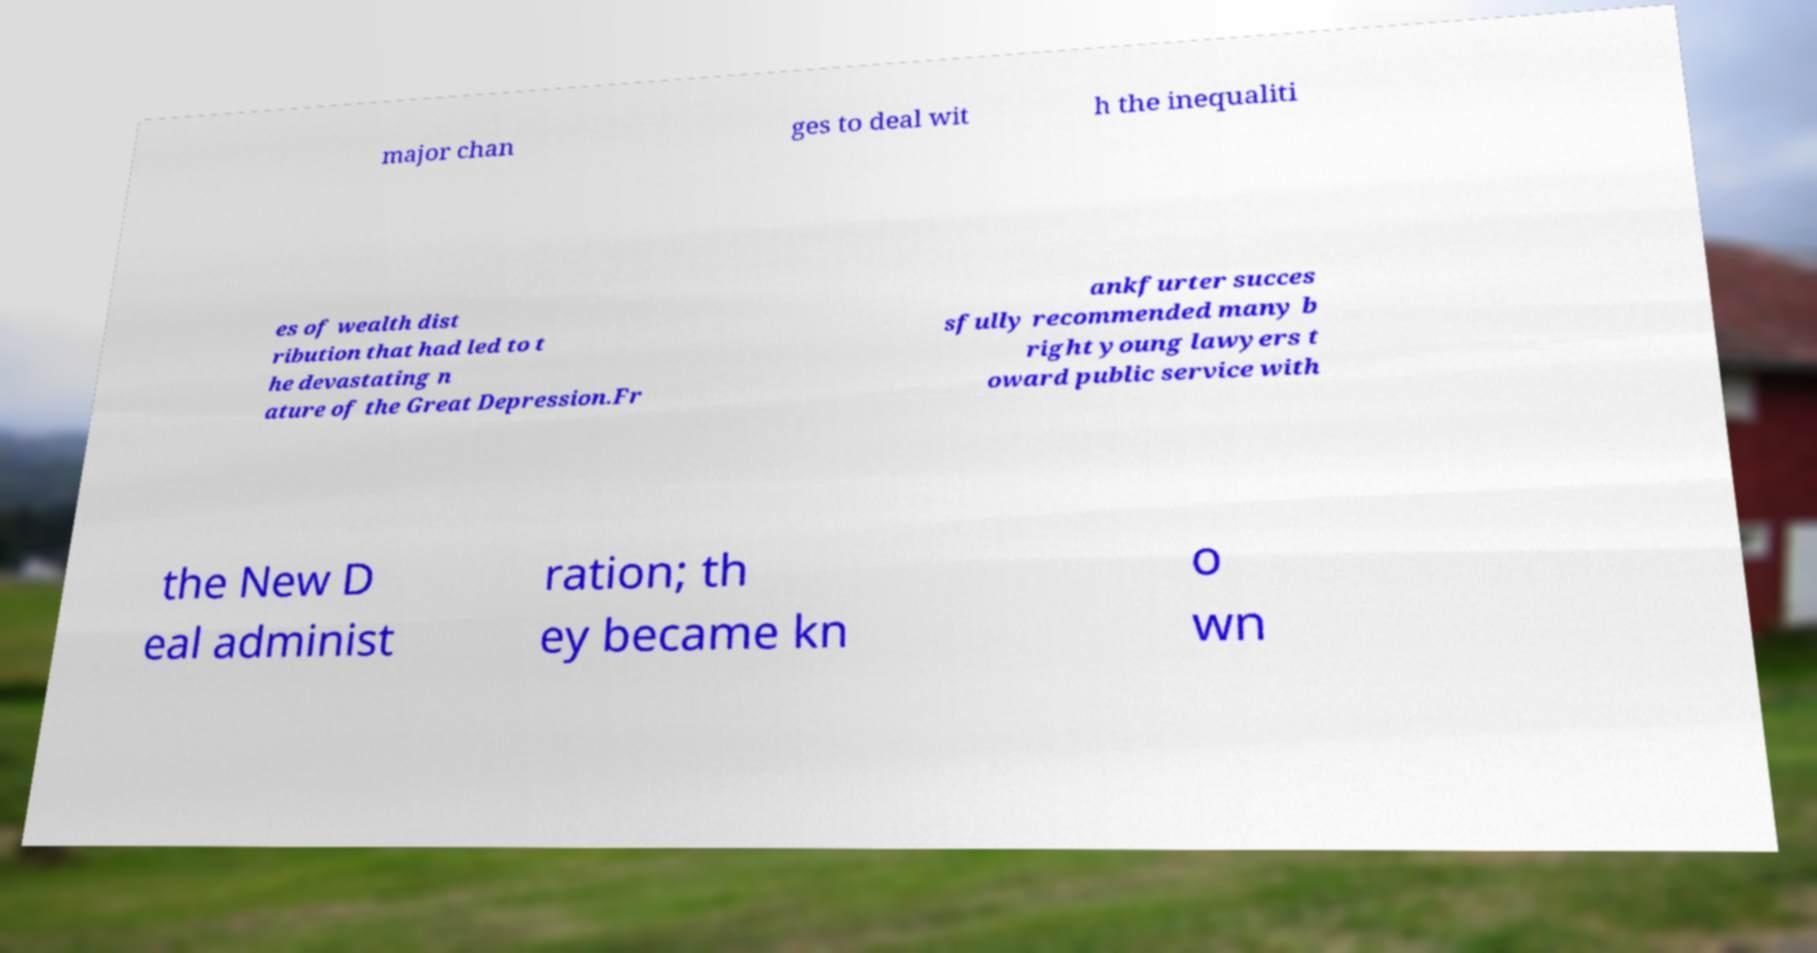There's text embedded in this image that I need extracted. Can you transcribe it verbatim? major chan ges to deal wit h the inequaliti es of wealth dist ribution that had led to t he devastating n ature of the Great Depression.Fr ankfurter succes sfully recommended many b right young lawyers t oward public service with the New D eal administ ration; th ey became kn o wn 